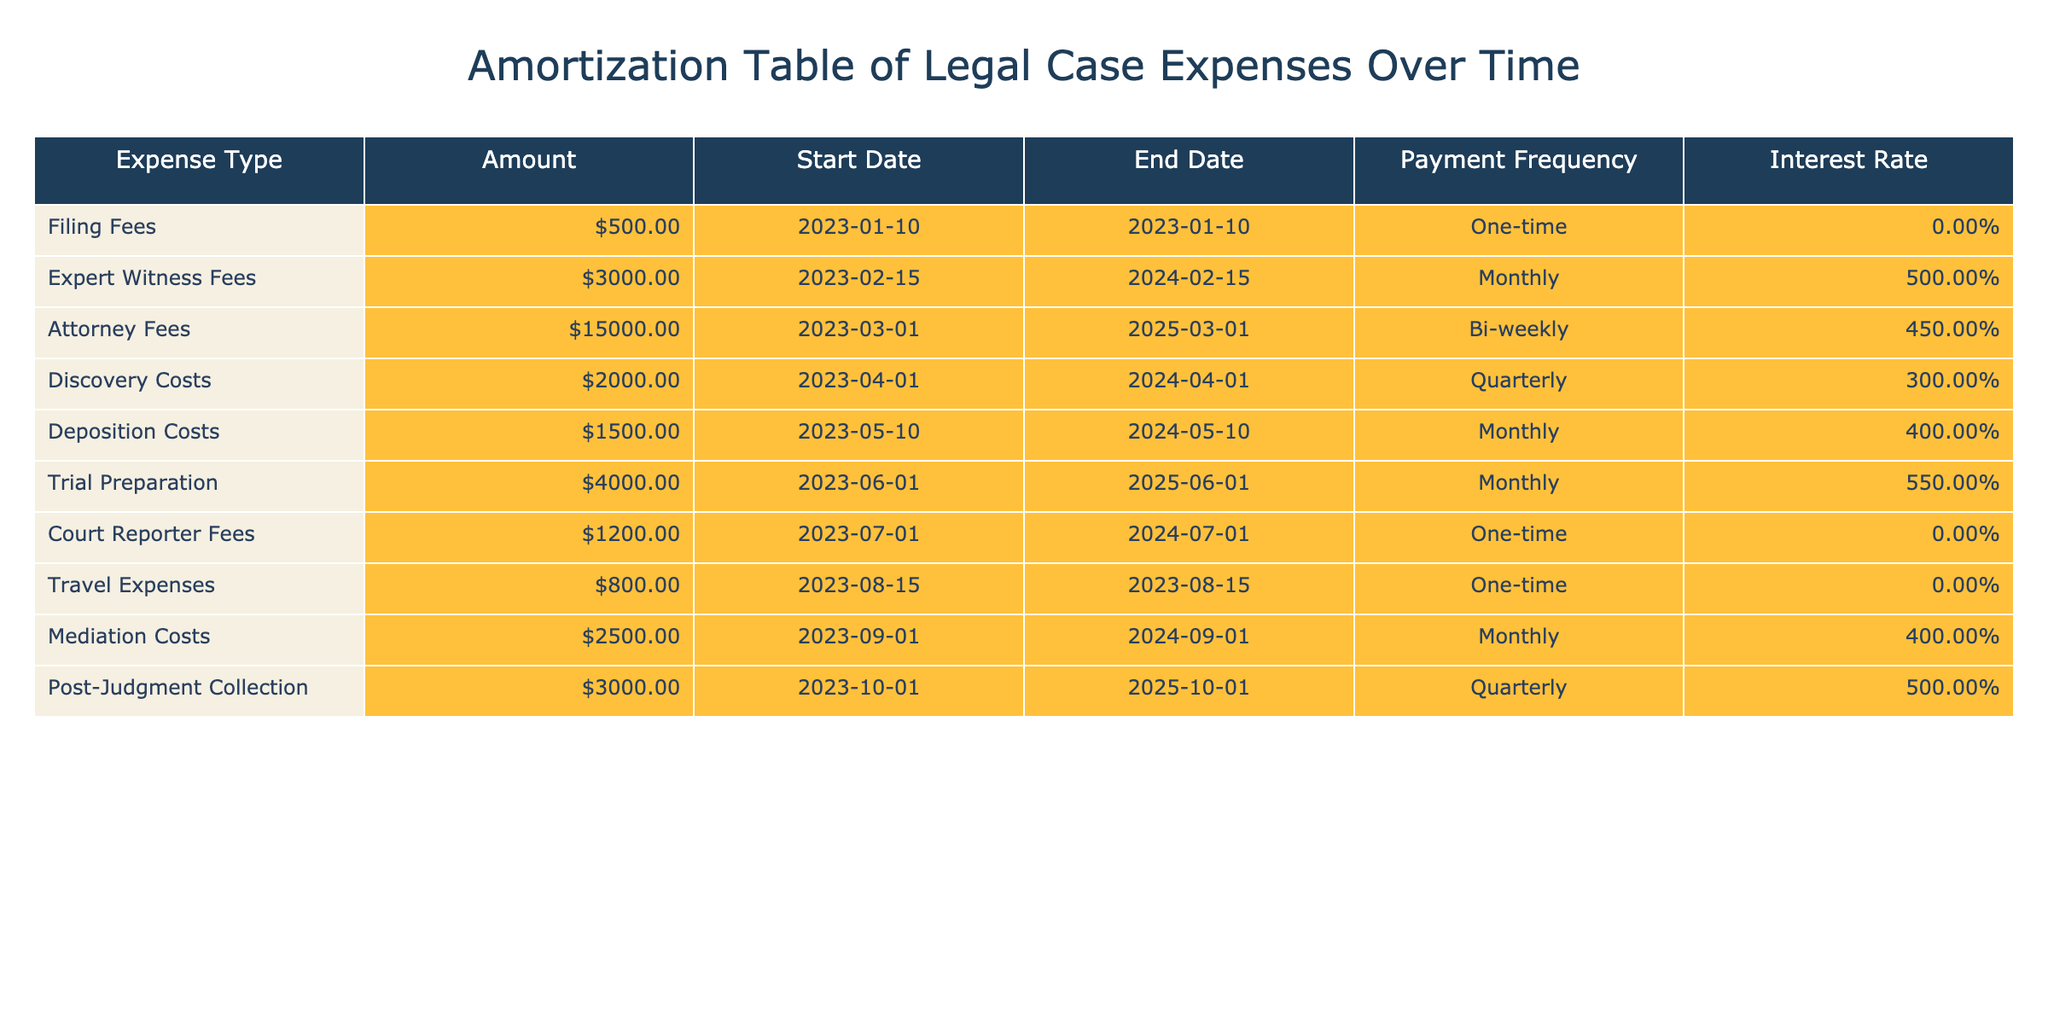What is the total amount of legal expenses listed in the table? To find the total amount, we sum all the individual amounts: 500 + 3000 + 15000 + 2000 + 1500 + 4000 + 1200 + 800 + 2500 + 3000 = 23600.
Answer: 23600 How many expense types are billed on a monthly basis? Upon reviewing the table, the expense types with a monthly payment frequency are: Expert Witness Fees, Deposition Costs, Trial Preparation, and Mediation Costs. This totals four expense types.
Answer: 4 What is the highest interest rate among the expenses? Looking at the interest rates in the table, they are: 0.00, 5.00, 4.50, 3.00, 4.00, 5.50, 0.00, 0.00, 4.00, and 5.00. The highest of these is 5.50.
Answer: 5.50 Are there any one-time expenses, and if so, what are they? The table lists several expense types with a one-time payment frequency: Filing Fees, Court Reporter Fees, and Travel Expenses.
Answer: Yes, Filing Fees, Court Reporter Fees, and Travel Expenses What is the total amount of fees incurred for trial preparation and attorney fees combined? The amount for Trial Preparation is 4000, and the amount for Attorney Fees is 15000. Adding these yields 4000 + 15000 = 19000.
Answer: 19000 What is the average payment amount for expenses that are billed quarterly? The quarterly expenses listed are Discovery Costs and Post-Judgment Collection, with amounts of 2000 and 3000 respectively. To find the average, sum these amounts (2000 + 3000 = 5000) and divide by 2, yielding 2500.
Answer: 2500 Which expense has the earliest start date? By inspecting the Start Date column, we see Filing Fees start on 2023-01-10, which is the earliest compared to all other expenses listed.
Answer: Filing Fees If all expenses are paid on time, how many total payments will be made for the Expert Witness Fees over its duration? The Expert Witness Fees start on 2023-02-15 and end a year later on 2024-02-15, with monthly payments. This results in 12 payments (one for each month).
Answer: 12 